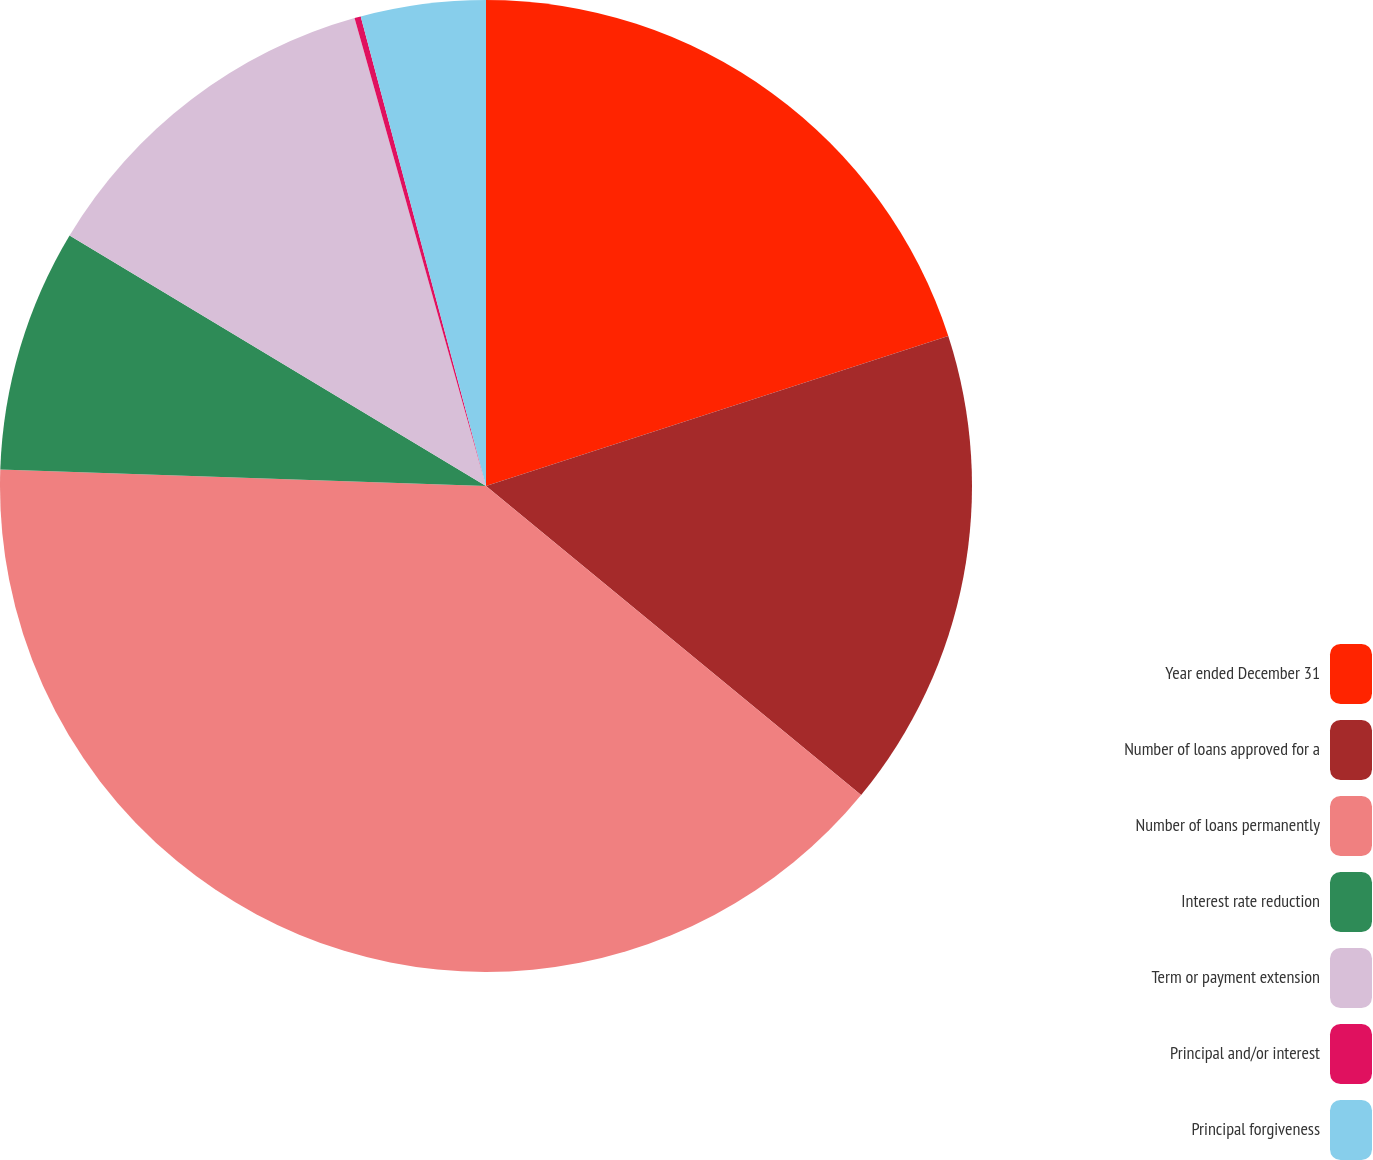Convert chart. <chart><loc_0><loc_0><loc_500><loc_500><pie_chart><fcel>Year ended December 31<fcel>Number of loans approved for a<fcel>Number of loans permanently<fcel>Interest rate reduction<fcel>Term or payment extension<fcel>Principal and/or interest<fcel>Principal forgiveness<nl><fcel>20.01%<fcel>15.96%<fcel>39.58%<fcel>8.08%<fcel>12.02%<fcel>0.21%<fcel>4.15%<nl></chart> 